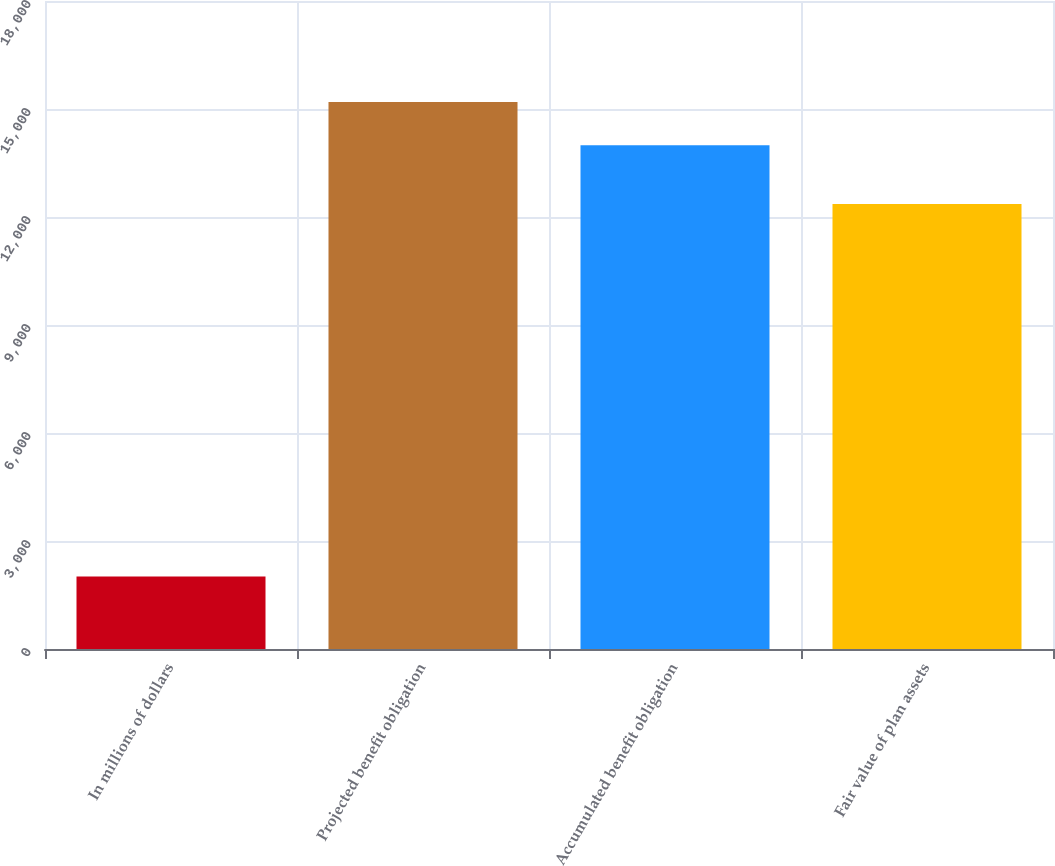Convert chart. <chart><loc_0><loc_0><loc_500><loc_500><bar_chart><fcel>In millions of dollars<fcel>Projected benefit obligation<fcel>Accumulated benefit obligation<fcel>Fair value of plan assets<nl><fcel>2016<fcel>15192.4<fcel>13994<fcel>12363<nl></chart> 